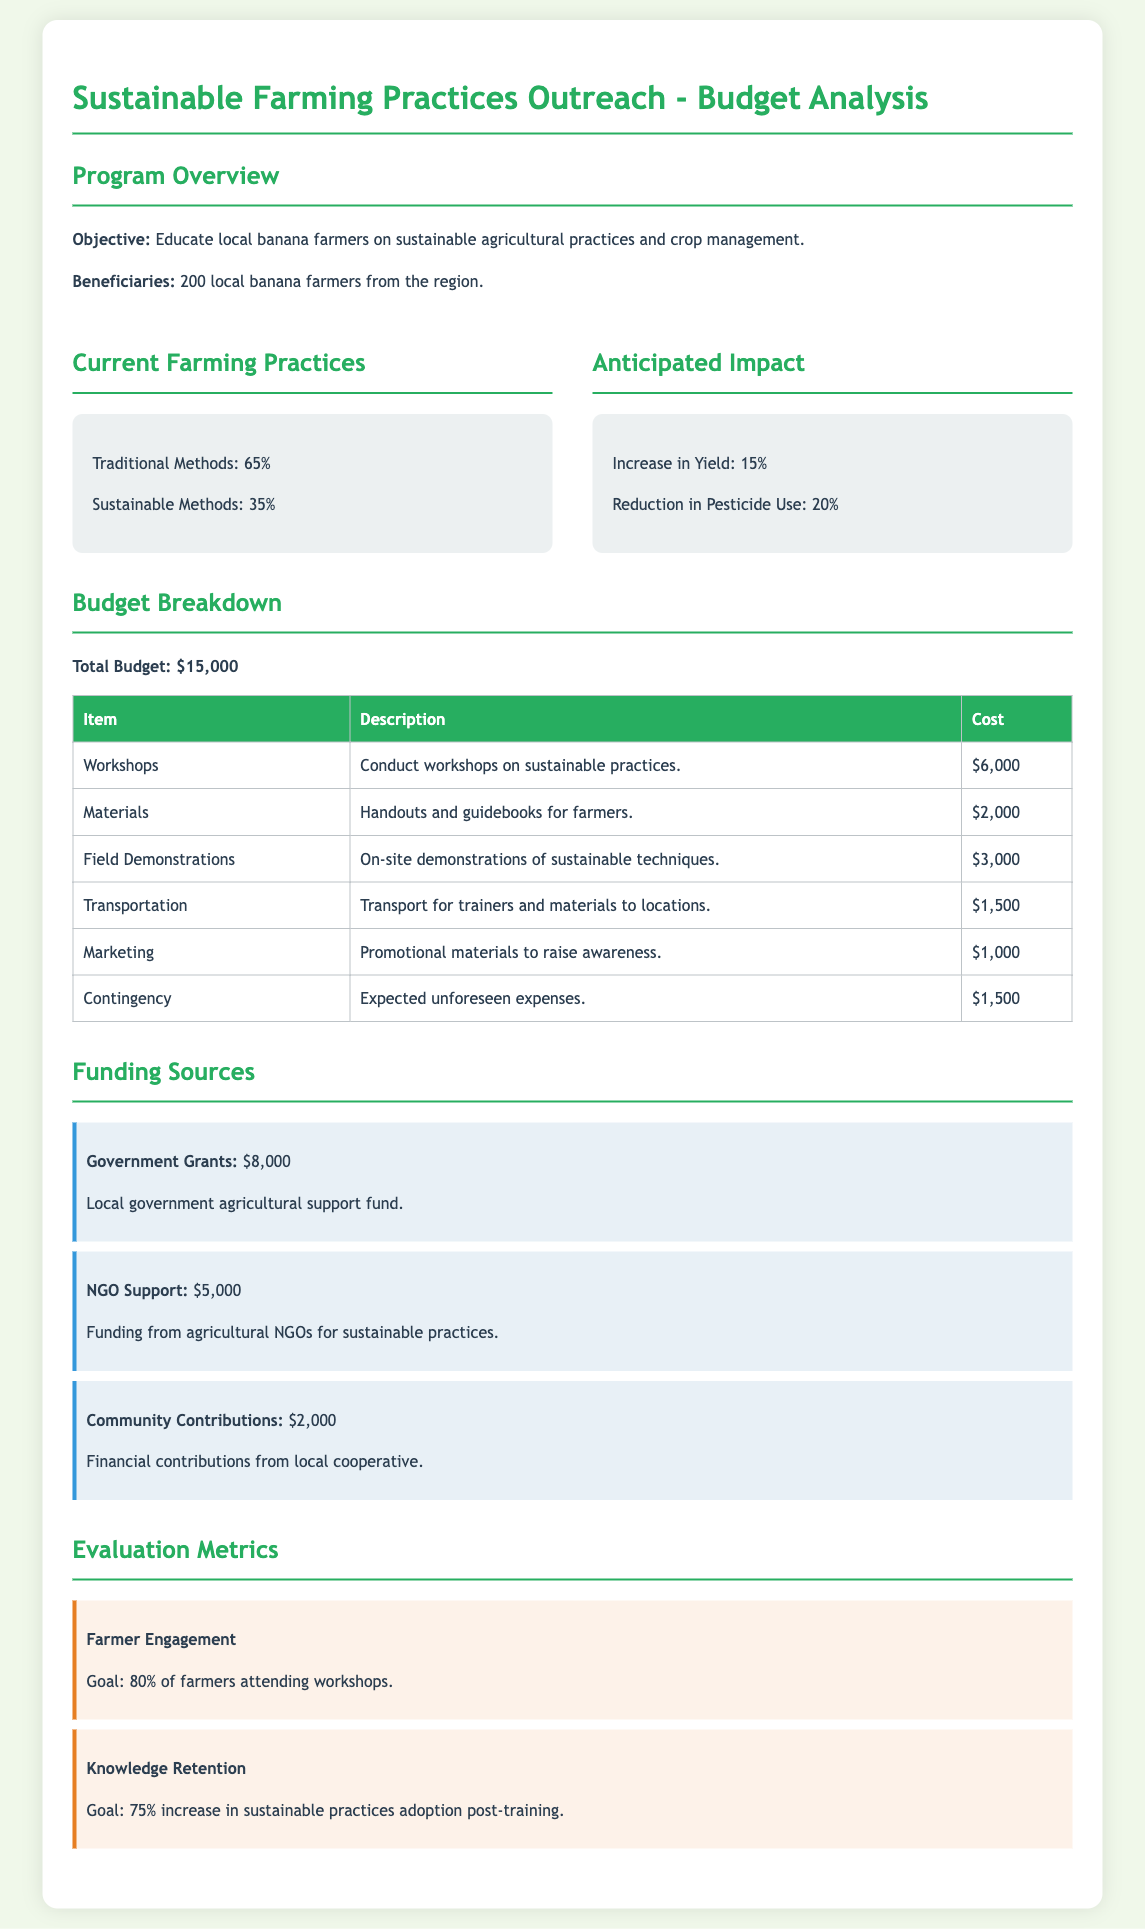What is the total budget? The total budget is stated in the document, which is $15,000.
Answer: $15,000 How many local banana farmers will benefit from the program? The document specifies that 200 local banana farmers will benefit from the program.
Answer: 200 What percentage of farmers currently use sustainable methods? The document indicates that 35% of farmers are currently using sustainable methods.
Answer: 35% What is the cost of field demonstrations? The document lists the cost of field demonstrations as $3,000.
Answer: $3,000 What is the goal for farmer engagement? The document specifies a goal of 80% of farmers attending workshops.
Answer: 80% How much funding comes from government grants? The document states that the funding from government grants is $8,000.
Answer: $8,000 What percentage increase in yield is anticipated? The document mentions that an increase in yield of 15% is anticipated.
Answer: 15% What amount is allocated for marketing? The budget breakdown indicates that the amount allocated for marketing is $1,000.
Answer: $1,000 What is the expected reduction in pesticide use? According to the document, the expected reduction in pesticide use is 20%.
Answer: 20% 